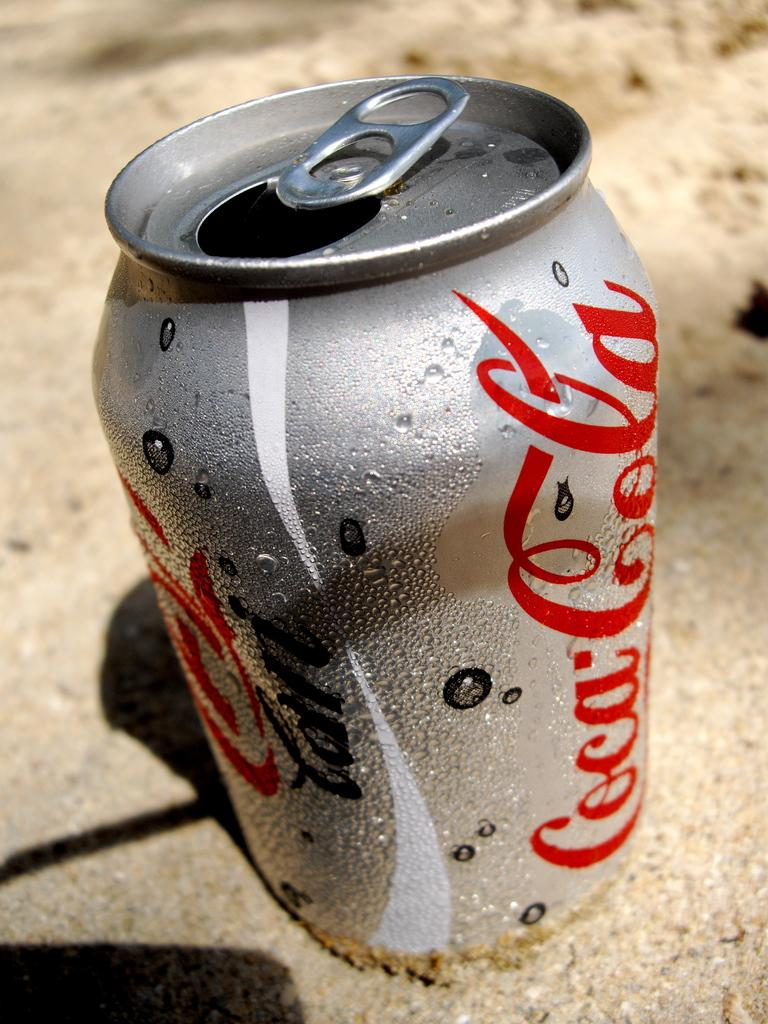<image>
Provide a brief description of the given image. Red and silver can saying Coca Cola on the ground. 